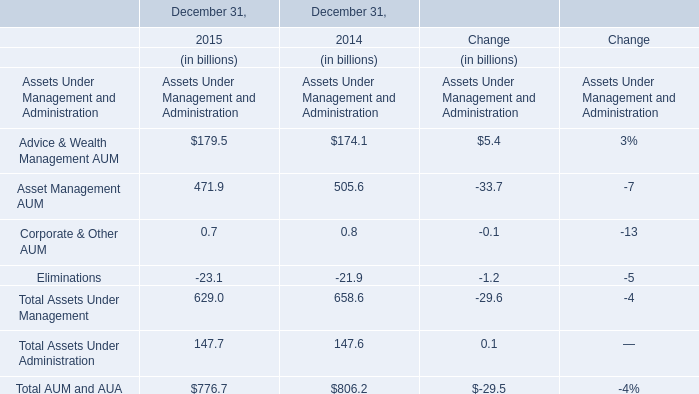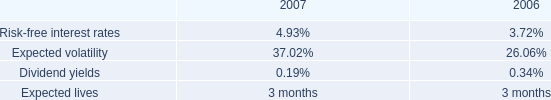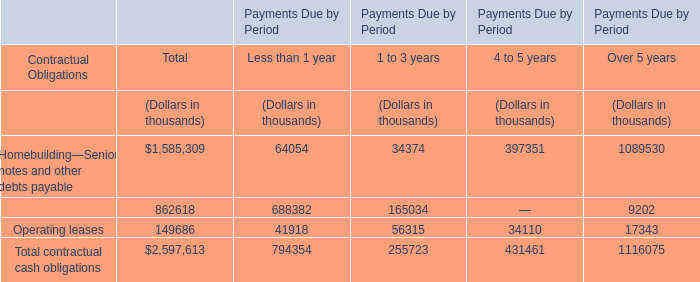What is the ratio of Asset Management AUM to the total in 2015? 
Computations: (471.9 / 776.7)
Answer: 0.60757. 